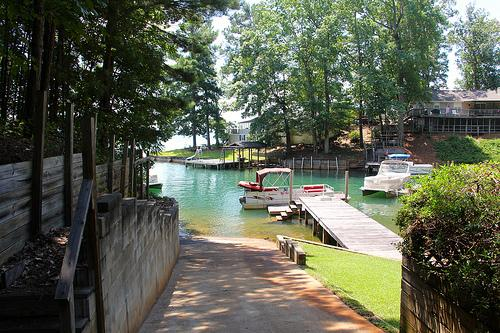What kind of advertisement could you create based on the content of this image? A serene lakeside retreat for relaxation, offering boat rides and scenic walks along the wooden dock and dirt path surrounded by nature. Which aspects of nature are clearly visible in the image? Tall green trees in the distance, short green grass on the ground, and a blue clear lake are visible. How would you describe the path in the image leading to the water? The path is a dirt path next to a stone wall and short green hedge. Mention two distinct features of the boat in the picture. The boat is white with a red trim and has a small canopy on it. Identify one unique element of the image and describe it. There is a large wooden building with many windows near the tall green trees. If you were to describe the dock in the image, what would you say about its appearance and material? The dock is made of light brown wood and has a small and brown pier. Describe the most dominant attributes of the trees in the image. The trees are very tall and green in color. What color is the lake water in the image? The lake water is a clear blue. What is the main activity happening in the image? A boat is docked by a wooden dock near the lake. 